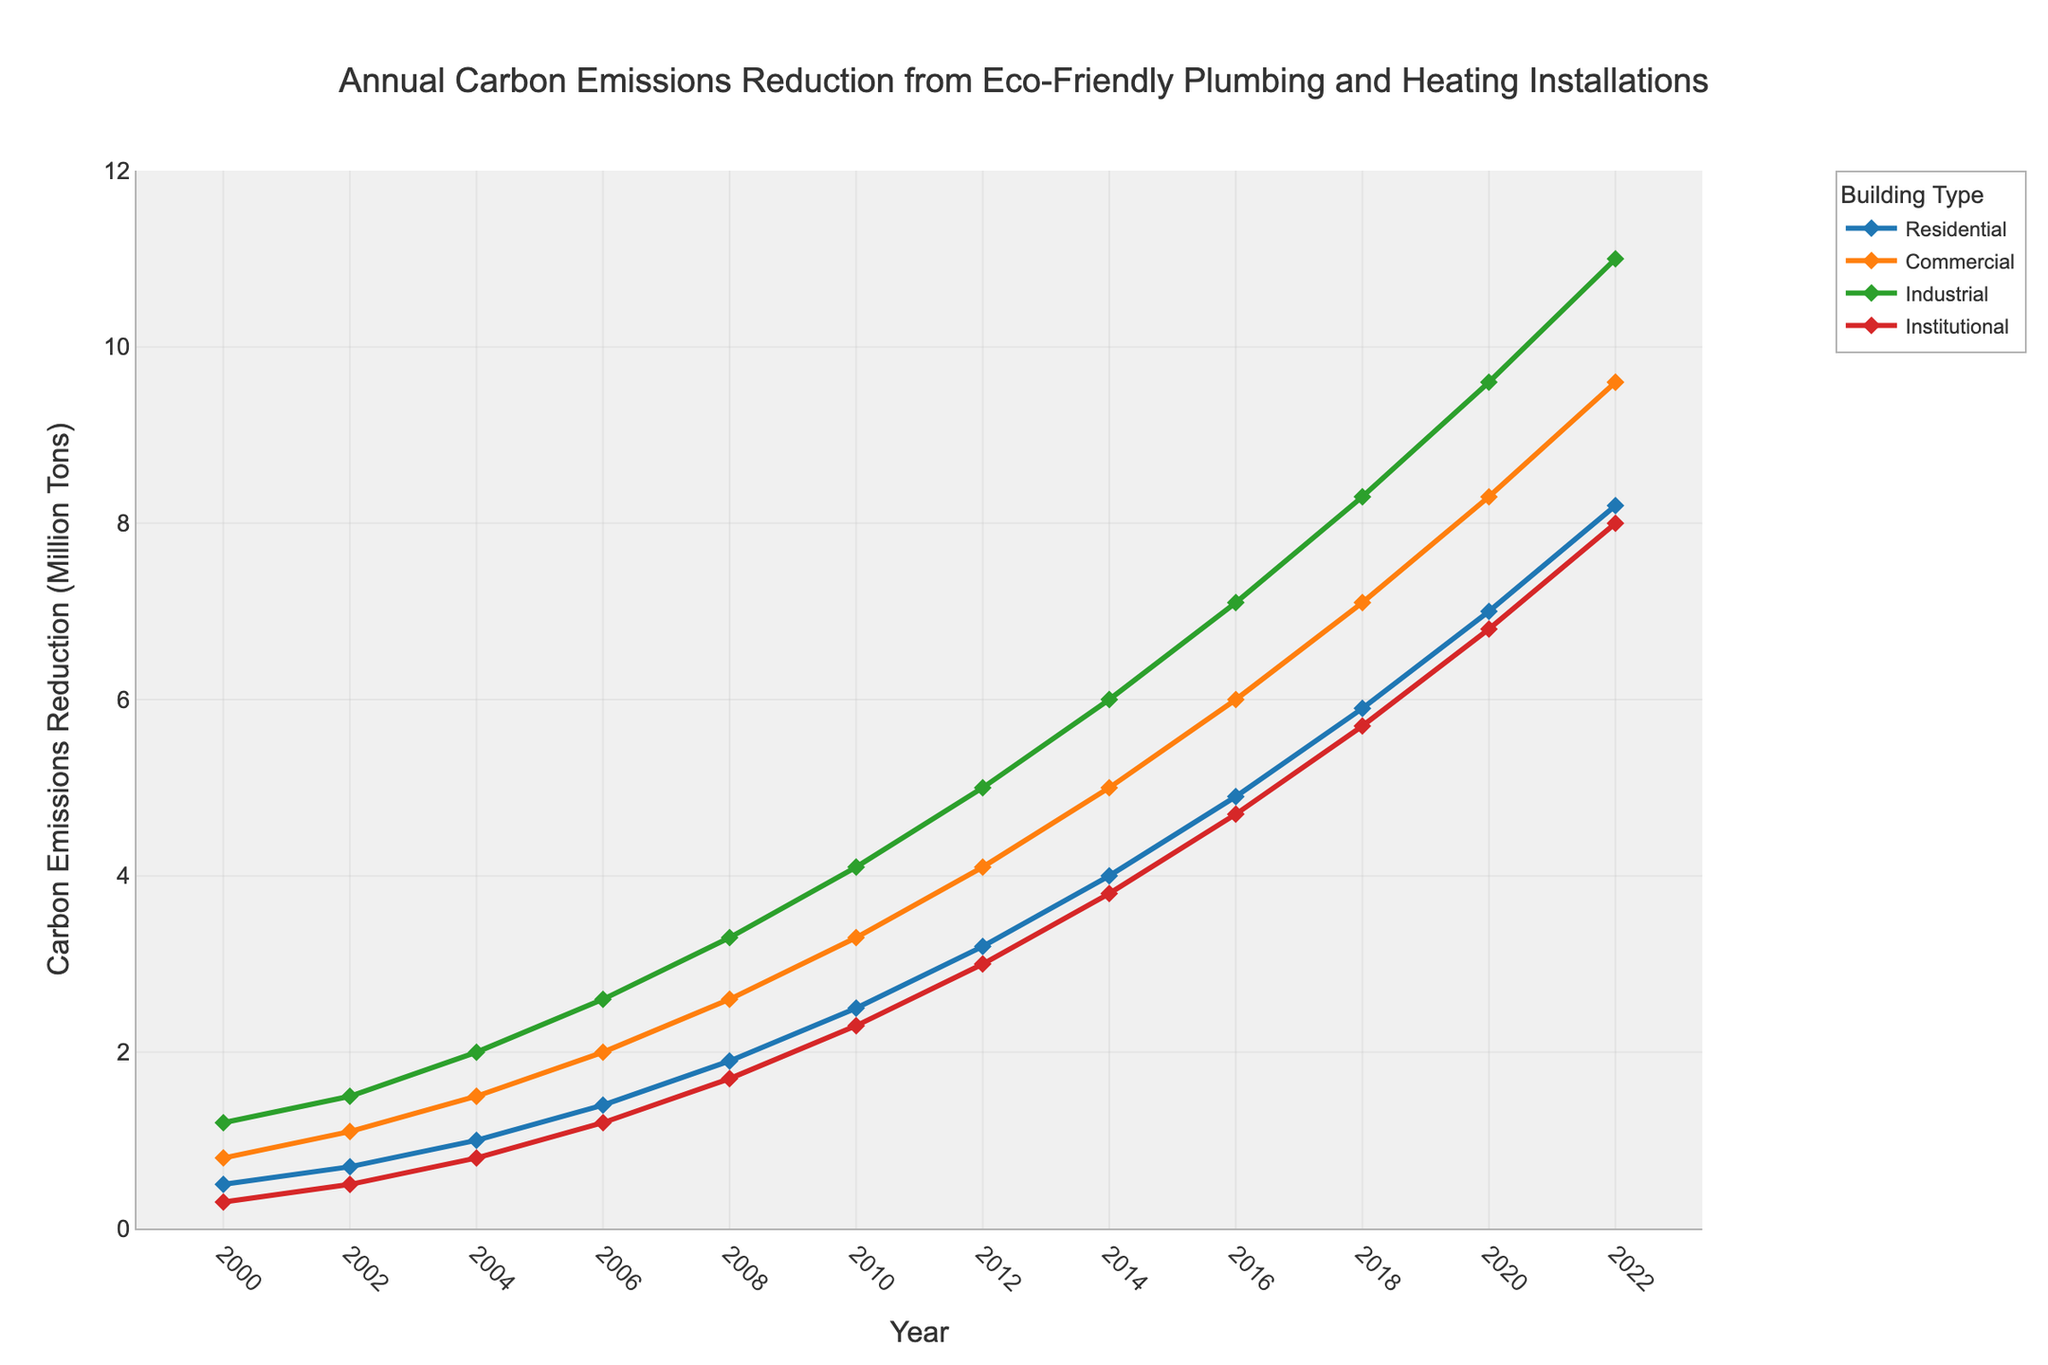What's the highest annual carbon emissions reduction achieved for residential buildings? Look at the "Residential" line, which is marked in blue, and find the maximum value. The highest point is at 2022, where the reduction is 8.2 million tons.
Answer: 8.2 million tons Which building type showed the largest increase in annual carbon emissions reduction between 2000 and 2022? Compare the reduction values for each building type in 2000 and 2022. The increases are: Residential (8.2 - 0.5 = 7.7), Commercial (9.6 - 0.8 = 8.8), Industrial (11.0 - 1.2 = 9.8), Institutional (8.0 - 0.3 = 7.7). The Industrial increase is the largest at 9.8 million tons.
Answer: Industrial By how much did the annual carbon emissions reduction for commercial buildings increase from 2016 to 2022? Locate the "Commercial" line, see the values for 2016 and 2022. The reduction increased from 6.0 to 9.6 million tons. Calculate the difference: 9.6 - 6.0 = 3.6 million tons.
Answer: 3.6 million tons Which building type had the smallest carbon emissions reduction in 2004? Look at the values for each building type in 2004. The values are: Residential (1.0), Commercial (1.5), Industrial (2.0), Institutional (0.8). The smallest value is for Institutional at 0.8 million tons.
Answer: Institutional How does the annual carbon emissions reduction trend for industrial buildings compare to that for institutional buildings over the years? Observe the trends: The "Industrial" line (green) has a steep and consistent upwards trend. The "Institutional" line (red) also goes up but at a less steep rate. Both show increases, but the Industrial trend is much steeper.
Answer: The Industrial trend is steeper What is the average annual carbon emissions reduction for residential buildings from 2010 to 2020? Find the values for 2010, 2012, 2014, 2016, 2018, and 2020. These are 2.5, 3.2, 4.0, 4.9, 5.9, and 7.0. Sum them: 2.5 + 3.2 + 4.0 + 4.9 + 5.9 + 7.0 = 27.5. Divide by the number of data points (6): 27.5 / 6 = 4.5833.
Answer: 4.58 million tons Between which two years did commercial buildings see the largest annual increase in carbon emissions reduction? Look at the "Commercial" line, calculate the differences between consecutive years. The largest increase is between 2010 (3.3) and 2012 (4.1), which is 0.8 million tons.
Answer: 2010 and 2012 What is the combined total of annual carbon emissions reduction for all building types in 2020? Find the values for 2020. They are Residential (7.0), Commercial (8.3), Industrial (9.6), Institutional (6.8). Sum them: 7.0 + 8.3 + 9.6 + 6.8 = 31.7 million tons.
Answer: 31.7 million tons How much greater was the carbon emissions reduction for industrial buildings compared to institutional buildings in 2022? In 2022, Industrial is at 11.0, and Institutional is at 8.0. Difference: 11.0 - 8.0 = 3.0 million tons.
Answer: 3.0 million tons Which building type had a steady increase from 2008 to 2018 and by how much did it increase over these years? Observe the lines: Look at "Commercial" from 2008 (2.6) to 2018 (7.1). Increase: 7.1 - 2.6 = 4.5 million tons.
Answer: Commercial, 4.5 million tons 